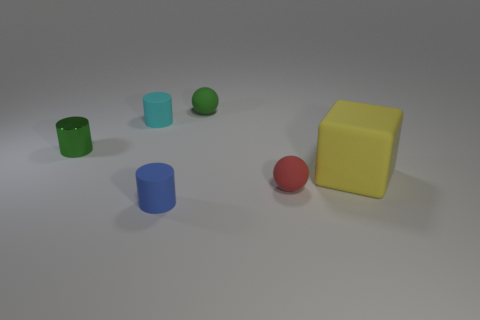Are there any other things that are made of the same material as the small green cylinder?
Provide a succinct answer. No. How many balls have the same size as the yellow cube?
Offer a terse response. 0. How many green objects are there?
Ensure brevity in your answer.  2. Is the cube made of the same material as the green thing that is right of the tiny blue rubber thing?
Give a very brief answer. Yes. How many yellow things are big matte objects or tiny rubber cylinders?
Offer a terse response. 1. There is a cyan thing that is the same material as the big yellow cube; what is its size?
Your answer should be very brief. Small. How many blue things have the same shape as the tiny cyan matte object?
Your response must be concise. 1. Is the number of large cubes in front of the blue cylinder greater than the number of shiny cylinders that are on the right side of the green rubber object?
Provide a succinct answer. No. There is a large rubber object; does it have the same color as the small matte object right of the green ball?
Your answer should be compact. No. There is a red thing that is the same size as the green shiny thing; what is its material?
Ensure brevity in your answer.  Rubber. 